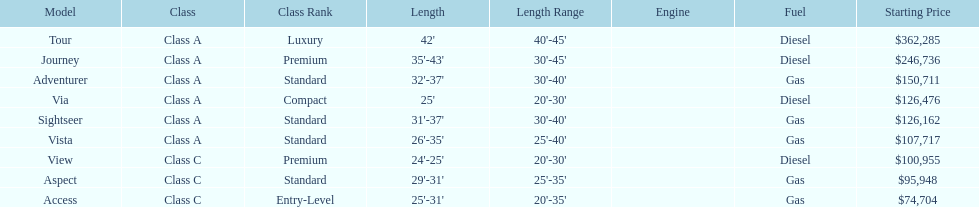Which winnebago model has the highest price tag? Tour. 